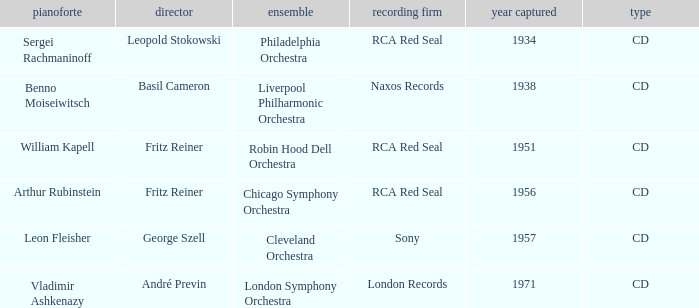Which orchestra has a recording year of 1951? Robin Hood Dell Orchestra. 